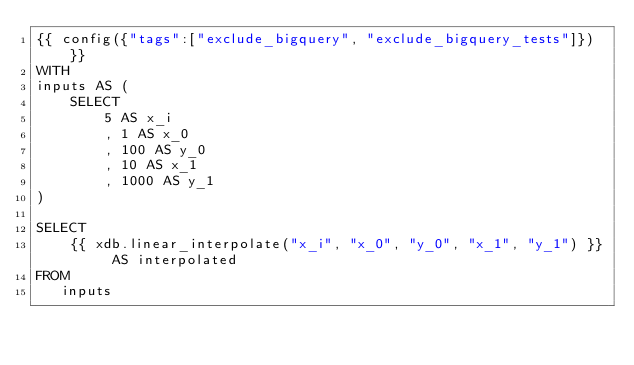Convert code to text. <code><loc_0><loc_0><loc_500><loc_500><_SQL_>{{ config({"tags":["exclude_bigquery", "exclude_bigquery_tests"]}) }}
WITH
inputs AS (
    SELECT
        5 AS x_i
        , 1 AS x_0
        , 100 AS y_0
        , 10 AS x_1
        , 1000 AS y_1
)
   
SELECT
    {{ xdb.linear_interpolate("x_i", "x_0", "y_0", "x_1", "y_1") }} AS interpolated
FROM
   inputs
</code> 